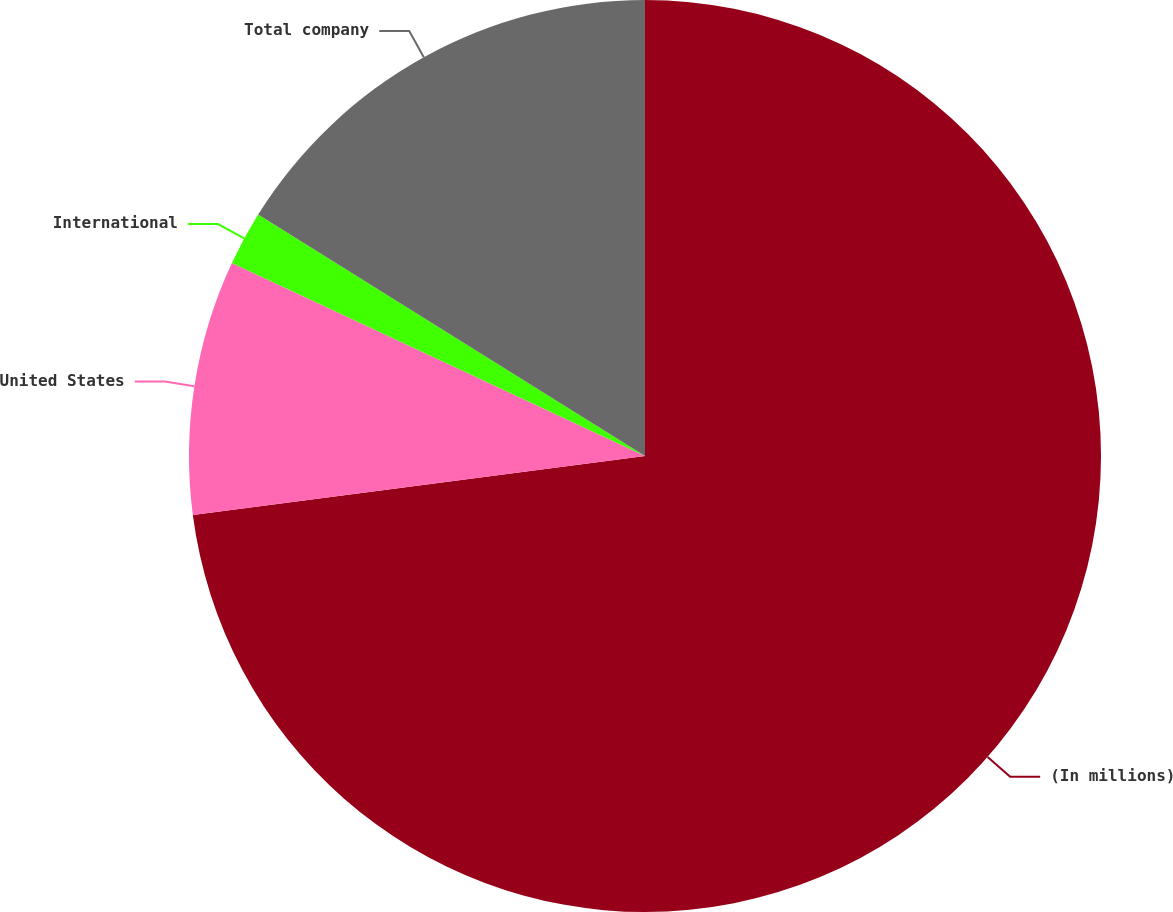Convert chart. <chart><loc_0><loc_0><loc_500><loc_500><pie_chart><fcel>(In millions)<fcel>United States<fcel>International<fcel>Total company<nl><fcel>72.93%<fcel>9.02%<fcel>1.92%<fcel>16.12%<nl></chart> 